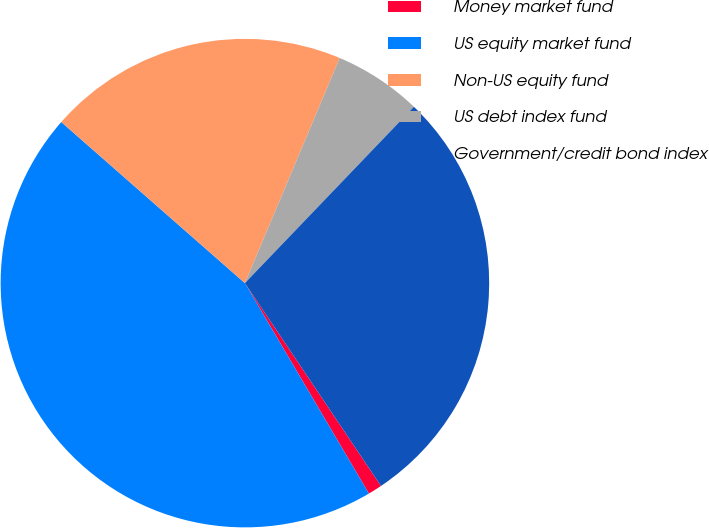Convert chart. <chart><loc_0><loc_0><loc_500><loc_500><pie_chart><fcel>Money market fund<fcel>US equity market fund<fcel>Non-US equity fund<fcel>US debt index fund<fcel>Government/credit bond index<nl><fcel>0.93%<fcel>44.93%<fcel>19.88%<fcel>5.82%<fcel>28.43%<nl></chart> 